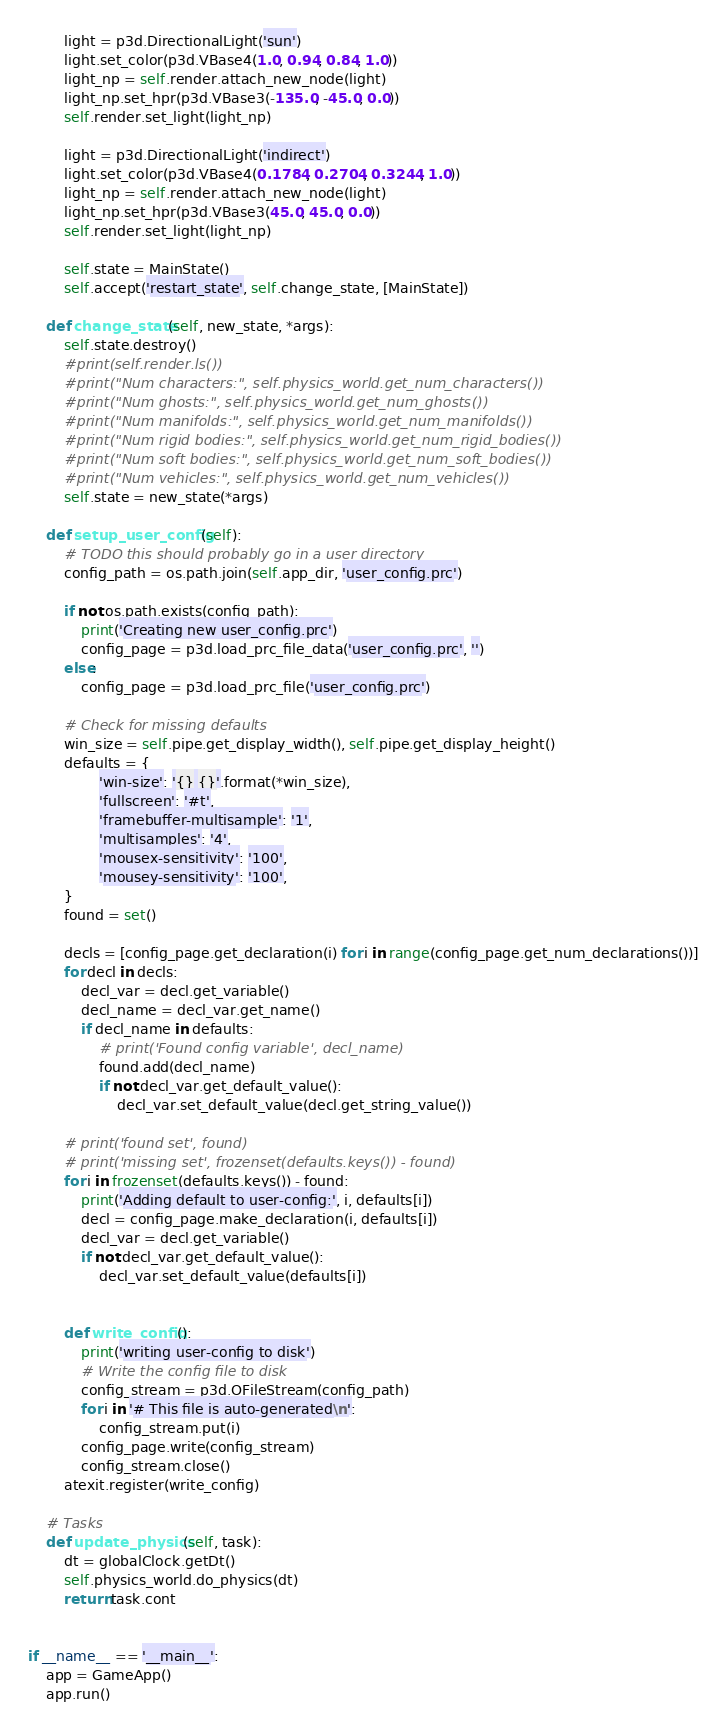<code> <loc_0><loc_0><loc_500><loc_500><_Python_>        light = p3d.DirectionalLight('sun')
        light.set_color(p3d.VBase4(1.0, 0.94, 0.84, 1.0))
        light_np = self.render.attach_new_node(light)
        light_np.set_hpr(p3d.VBase3(-135.0, -45.0, 0.0))
        self.render.set_light(light_np)

        light = p3d.DirectionalLight('indirect')
        light.set_color(p3d.VBase4(0.1784, 0.2704, 0.3244, 1.0))
        light_np = self.render.attach_new_node(light)
        light_np.set_hpr(p3d.VBase3(45.0, 45.0, 0.0))
        self.render.set_light(light_np)

        self.state = MainState()
        self.accept('restart_state', self.change_state, [MainState])

    def change_state(self, new_state, *args):
        self.state.destroy()
        #print(self.render.ls())
        #print("Num characters:", self.physics_world.get_num_characters())
        #print("Num ghosts:", self.physics_world.get_num_ghosts())
        #print("Num manifolds:", self.physics_world.get_num_manifolds())
        #print("Num rigid bodies:", self.physics_world.get_num_rigid_bodies())
        #print("Num soft bodies:", self.physics_world.get_num_soft_bodies())
        #print("Num vehicles:", self.physics_world.get_num_vehicles())
        self.state = new_state(*args)

    def setup_user_config(self):
        # TODO this should probably go in a user directory
        config_path = os.path.join(self.app_dir, 'user_config.prc')

        if not os.path.exists(config_path):
            print('Creating new user_config.prc')
            config_page = p3d.load_prc_file_data('user_config.prc', '')
        else:
            config_page = p3d.load_prc_file('user_config.prc')

        # Check for missing defaults
        win_size = self.pipe.get_display_width(), self.pipe.get_display_height()
        defaults = {
                'win-size': '{} {}'.format(*win_size),
                'fullscreen': '#t',
                'framebuffer-multisample': '1',
                'multisamples': '4',
                'mousex-sensitivity': '100',
                'mousey-sensitivity': '100',
        }
        found = set()

        decls = [config_page.get_declaration(i) for i in range(config_page.get_num_declarations())]
        for decl in decls:
            decl_var = decl.get_variable()
            decl_name = decl_var.get_name()
            if decl_name in defaults:
                # print('Found config variable', decl_name)
                found.add(decl_name)
                if not decl_var.get_default_value():
                    decl_var.set_default_value(decl.get_string_value())

        # print('found set', found)
        # print('missing set', frozenset(defaults.keys()) - found)
        for i in frozenset(defaults.keys()) - found:
            print('Adding default to user-config:', i, defaults[i])
            decl = config_page.make_declaration(i, defaults[i])
            decl_var = decl.get_variable()
            if not decl_var.get_default_value():
                decl_var.set_default_value(defaults[i])


        def write_config():
            print('writing user-config to disk')
            # Write the config file to disk
            config_stream = p3d.OFileStream(config_path)
            for i in '# This file is auto-generated\n':
                config_stream.put(i)
            config_page.write(config_stream)
            config_stream.close()
        atexit.register(write_config)

    # Tasks
    def update_physics(self, task):
        dt = globalClock.getDt()
        self.physics_world.do_physics(dt)
        return task.cont


if __name__ == '__main__':
    app = GameApp()
    app.run()
</code> 